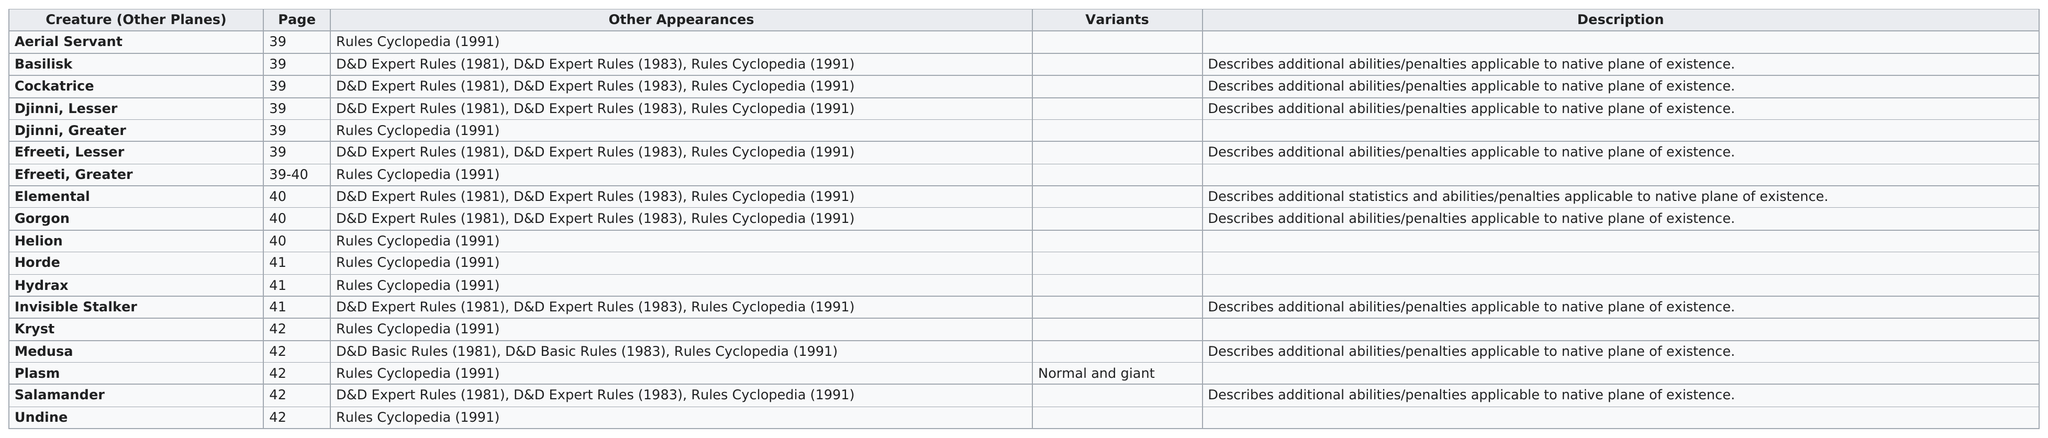List a handful of essential elements in this visual. The last creature in the list for page 41 is the Invisible Stalker, which is a creature from the plane of Invisible Sun. The page number of the last line is 42. There are four creatures on page 40. The description next to Medusa highlights any additional abilities or penalties associated with her native plane of existence. Basilisk is being pursued by a creature known as a cockatrice. 